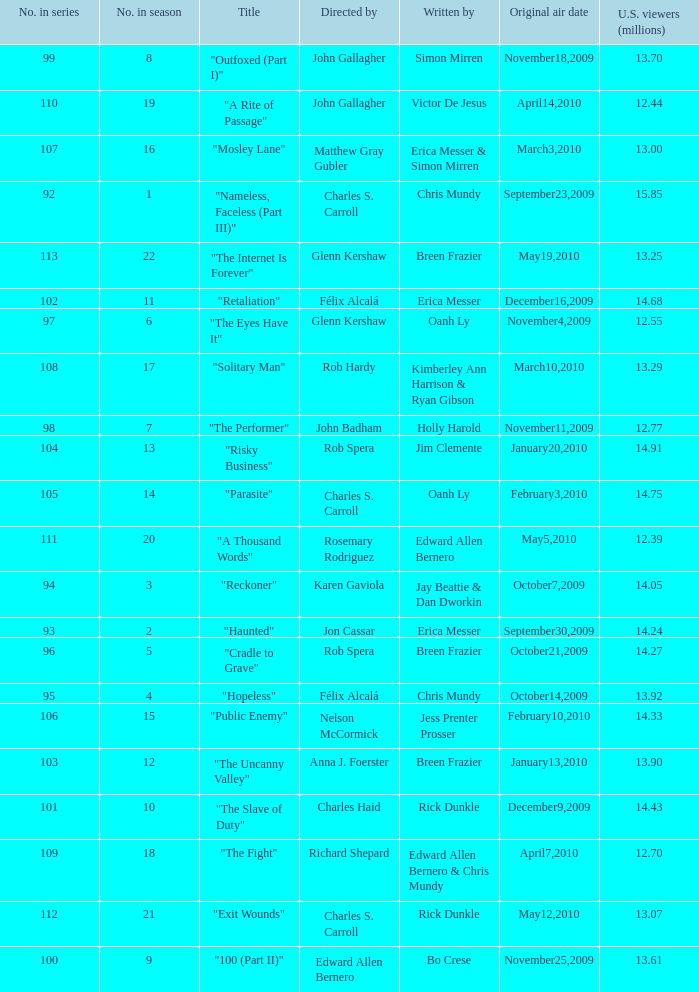I'm looking to parse the entire table for insights. Could you assist me with that? {'header': ['No. in series', 'No. in season', 'Title', 'Directed by', 'Written by', 'Original air date', 'U.S. viewers (millions)'], 'rows': [['99', '8', '"Outfoxed (Part I)"', 'John Gallagher', 'Simon Mirren', 'November18,2009', '13.70'], ['110', '19', '"A Rite of Passage"', 'John Gallagher', 'Victor De Jesus', 'April14,2010', '12.44'], ['107', '16', '"Mosley Lane"', 'Matthew Gray Gubler', 'Erica Messer & Simon Mirren', 'March3,2010', '13.00'], ['92', '1', '"Nameless, Faceless (Part III)"', 'Charles S. Carroll', 'Chris Mundy', 'September23,2009', '15.85'], ['113', '22', '"The Internet Is Forever"', 'Glenn Kershaw', 'Breen Frazier', 'May19,2010', '13.25'], ['102', '11', '"Retaliation"', 'Félix Alcalá', 'Erica Messer', 'December16,2009', '14.68'], ['97', '6', '"The Eyes Have It"', 'Glenn Kershaw', 'Oanh Ly', 'November4,2009', '12.55'], ['108', '17', '"Solitary Man"', 'Rob Hardy', 'Kimberley Ann Harrison & Ryan Gibson', 'March10,2010', '13.29'], ['98', '7', '"The Performer"', 'John Badham', 'Holly Harold', 'November11,2009', '12.77'], ['104', '13', '"Risky Business"', 'Rob Spera', 'Jim Clemente', 'January20,2010', '14.91'], ['105', '14', '"Parasite"', 'Charles S. Carroll', 'Oanh Ly', 'February3,2010', '14.75'], ['111', '20', '"A Thousand Words"', 'Rosemary Rodriguez', 'Edward Allen Bernero', 'May5,2010', '12.39'], ['94', '3', '"Reckoner"', 'Karen Gaviola', 'Jay Beattie & Dan Dworkin', 'October7,2009', '14.05'], ['93', '2', '"Haunted"', 'Jon Cassar', 'Erica Messer', 'September30,2009', '14.24'], ['96', '5', '"Cradle to Grave"', 'Rob Spera', 'Breen Frazier', 'October21,2009', '14.27'], ['95', '4', '"Hopeless"', 'Félix Alcalá', 'Chris Mundy', 'October14,2009', '13.92'], ['106', '15', '"Public Enemy"', 'Nelson McCormick', 'Jess Prenter Prosser', 'February10,2010', '14.33'], ['103', '12', '"The Uncanny Valley"', 'Anna J. Foerster', 'Breen Frazier', 'January13,2010', '13.90'], ['101', '10', '"The Slave of Duty"', 'Charles Haid', 'Rick Dunkle', 'December9,2009', '14.43'], ['109', '18', '"The Fight"', 'Richard Shepard', 'Edward Allen Bernero & Chris Mundy', 'April7,2010', '12.70'], ['112', '21', '"Exit Wounds"', 'Charles S. Carroll', 'Rick Dunkle', 'May12,2010', '13.07'], ['100', '9', '"100 (Part II)"', 'Edward Allen Bernero', 'Bo Crese', 'November25,2009', '13.61']]} What number(s) in the series was written by bo crese? 100.0. 